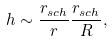Convert formula to latex. <formula><loc_0><loc_0><loc_500><loc_500>h \sim \frac { r _ { s c h } } { r } \frac { r _ { s c h } } { R } ,</formula> 